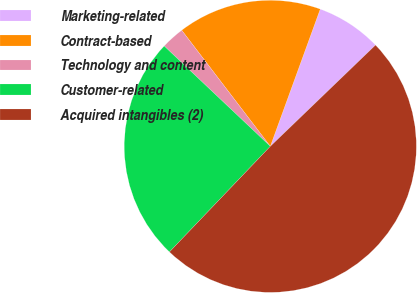<chart> <loc_0><loc_0><loc_500><loc_500><pie_chart><fcel>Marketing-related<fcel>Contract-based<fcel>Technology and content<fcel>Customer-related<fcel>Acquired intangibles (2)<nl><fcel>7.25%<fcel>15.93%<fcel>2.57%<fcel>24.92%<fcel>49.33%<nl></chart> 